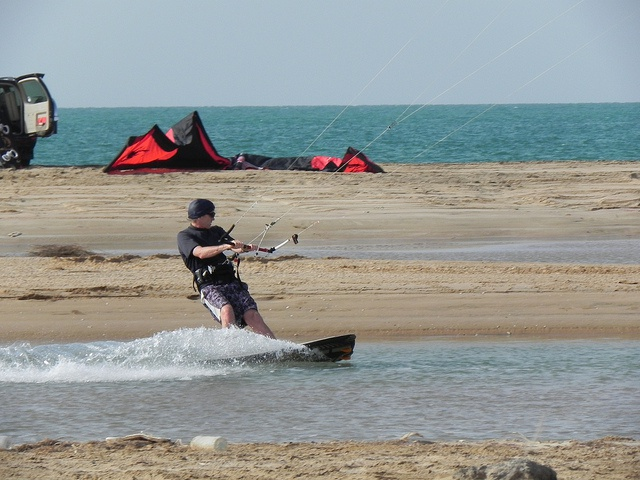Describe the objects in this image and their specific colors. I can see people in darkgray, black, gray, and tan tones, car in darkgray, black, gray, and lightgray tones, and surfboard in darkgray, black, and gray tones in this image. 